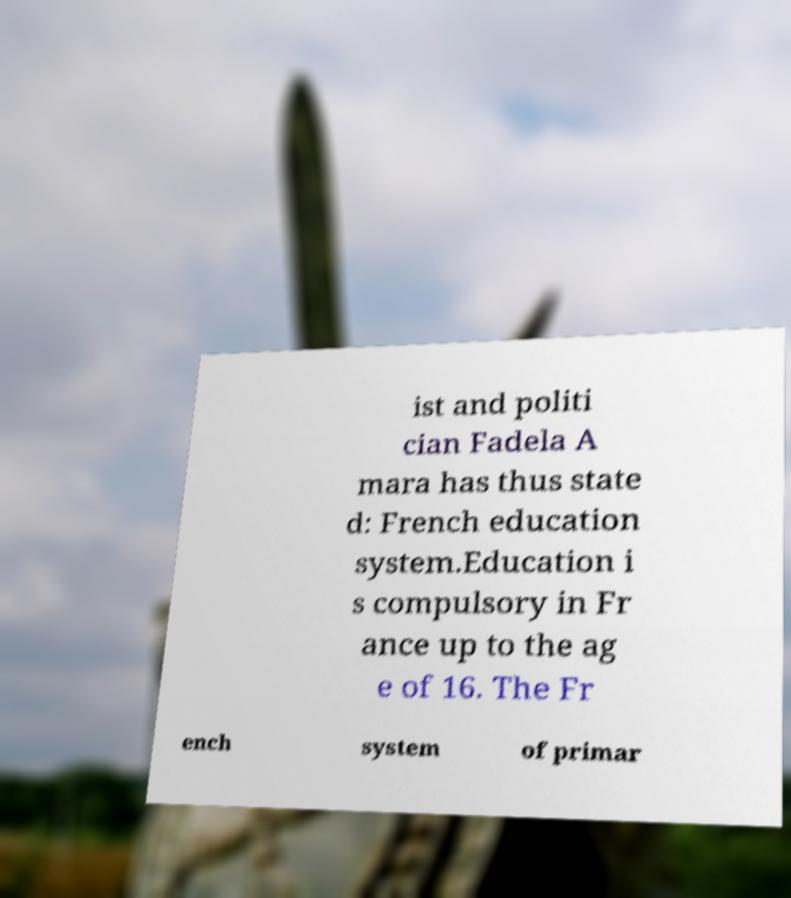Could you assist in decoding the text presented in this image and type it out clearly? ist and politi cian Fadela A mara has thus state d: French education system.Education i s compulsory in Fr ance up to the ag e of 16. The Fr ench system of primar 